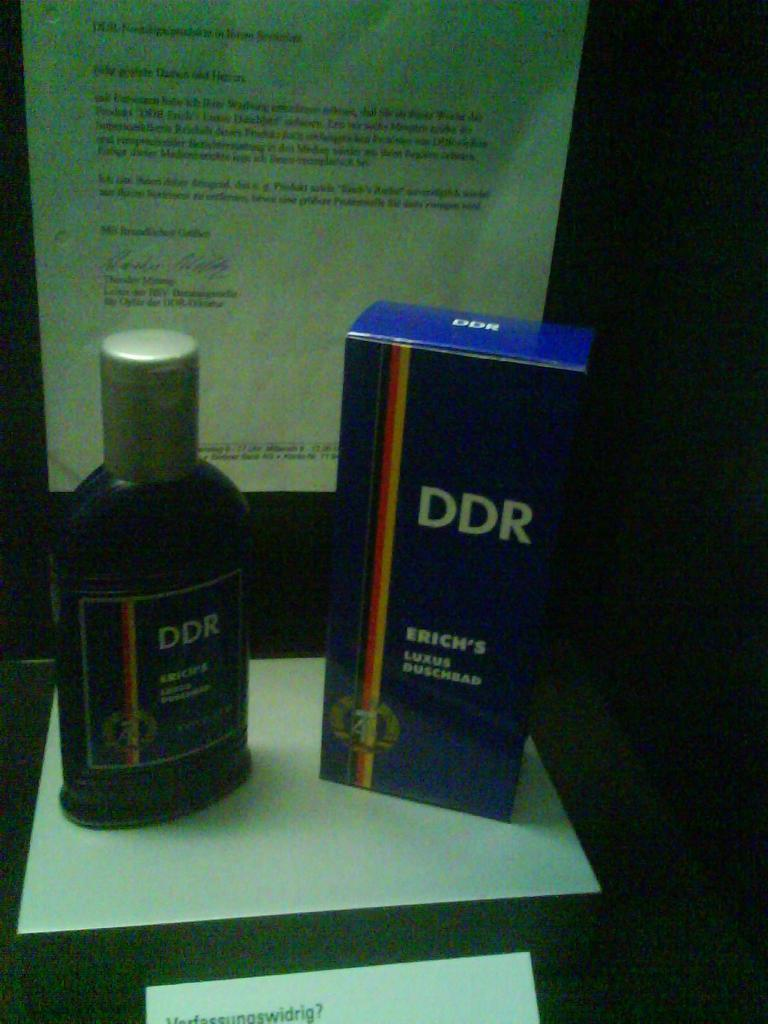<image>
Offer a succinct explanation of the picture presented. A blue bottle of DDR Erich's Luxus Buschbad. 